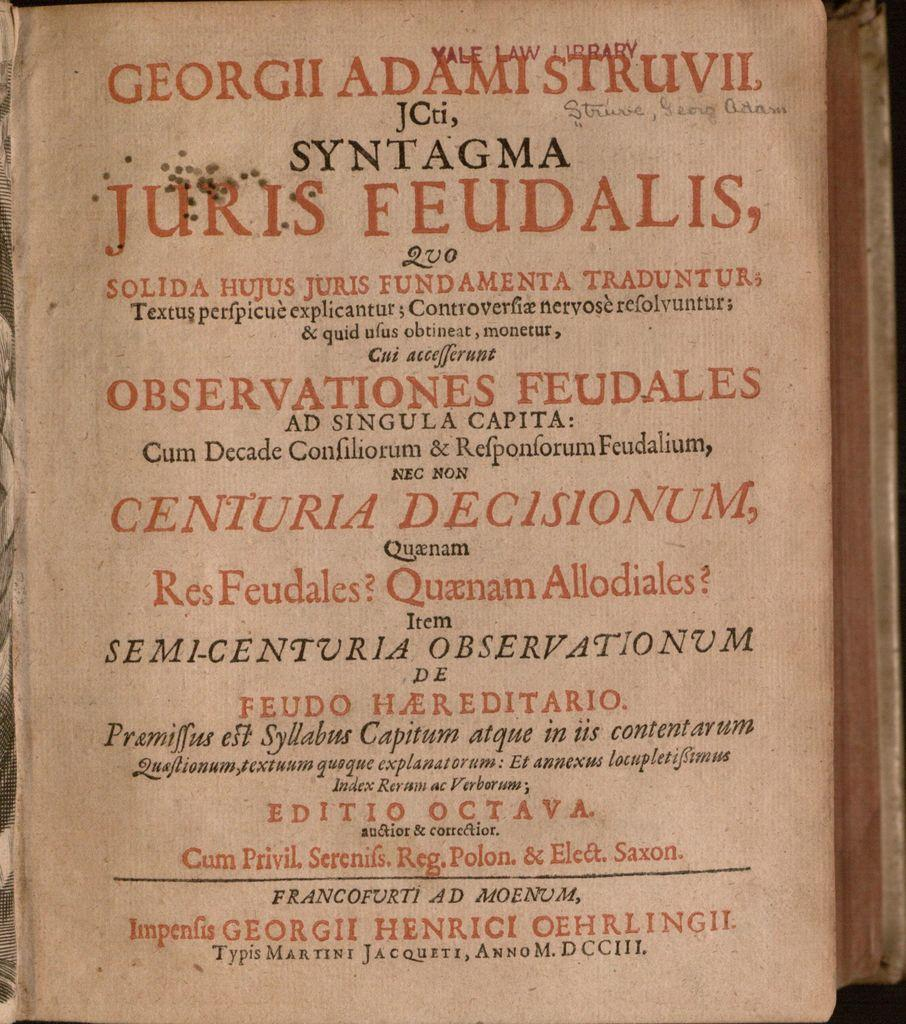<image>
Present a compact description of the photo's key features. A sign in a foreign language is about Juris Feudalis. 